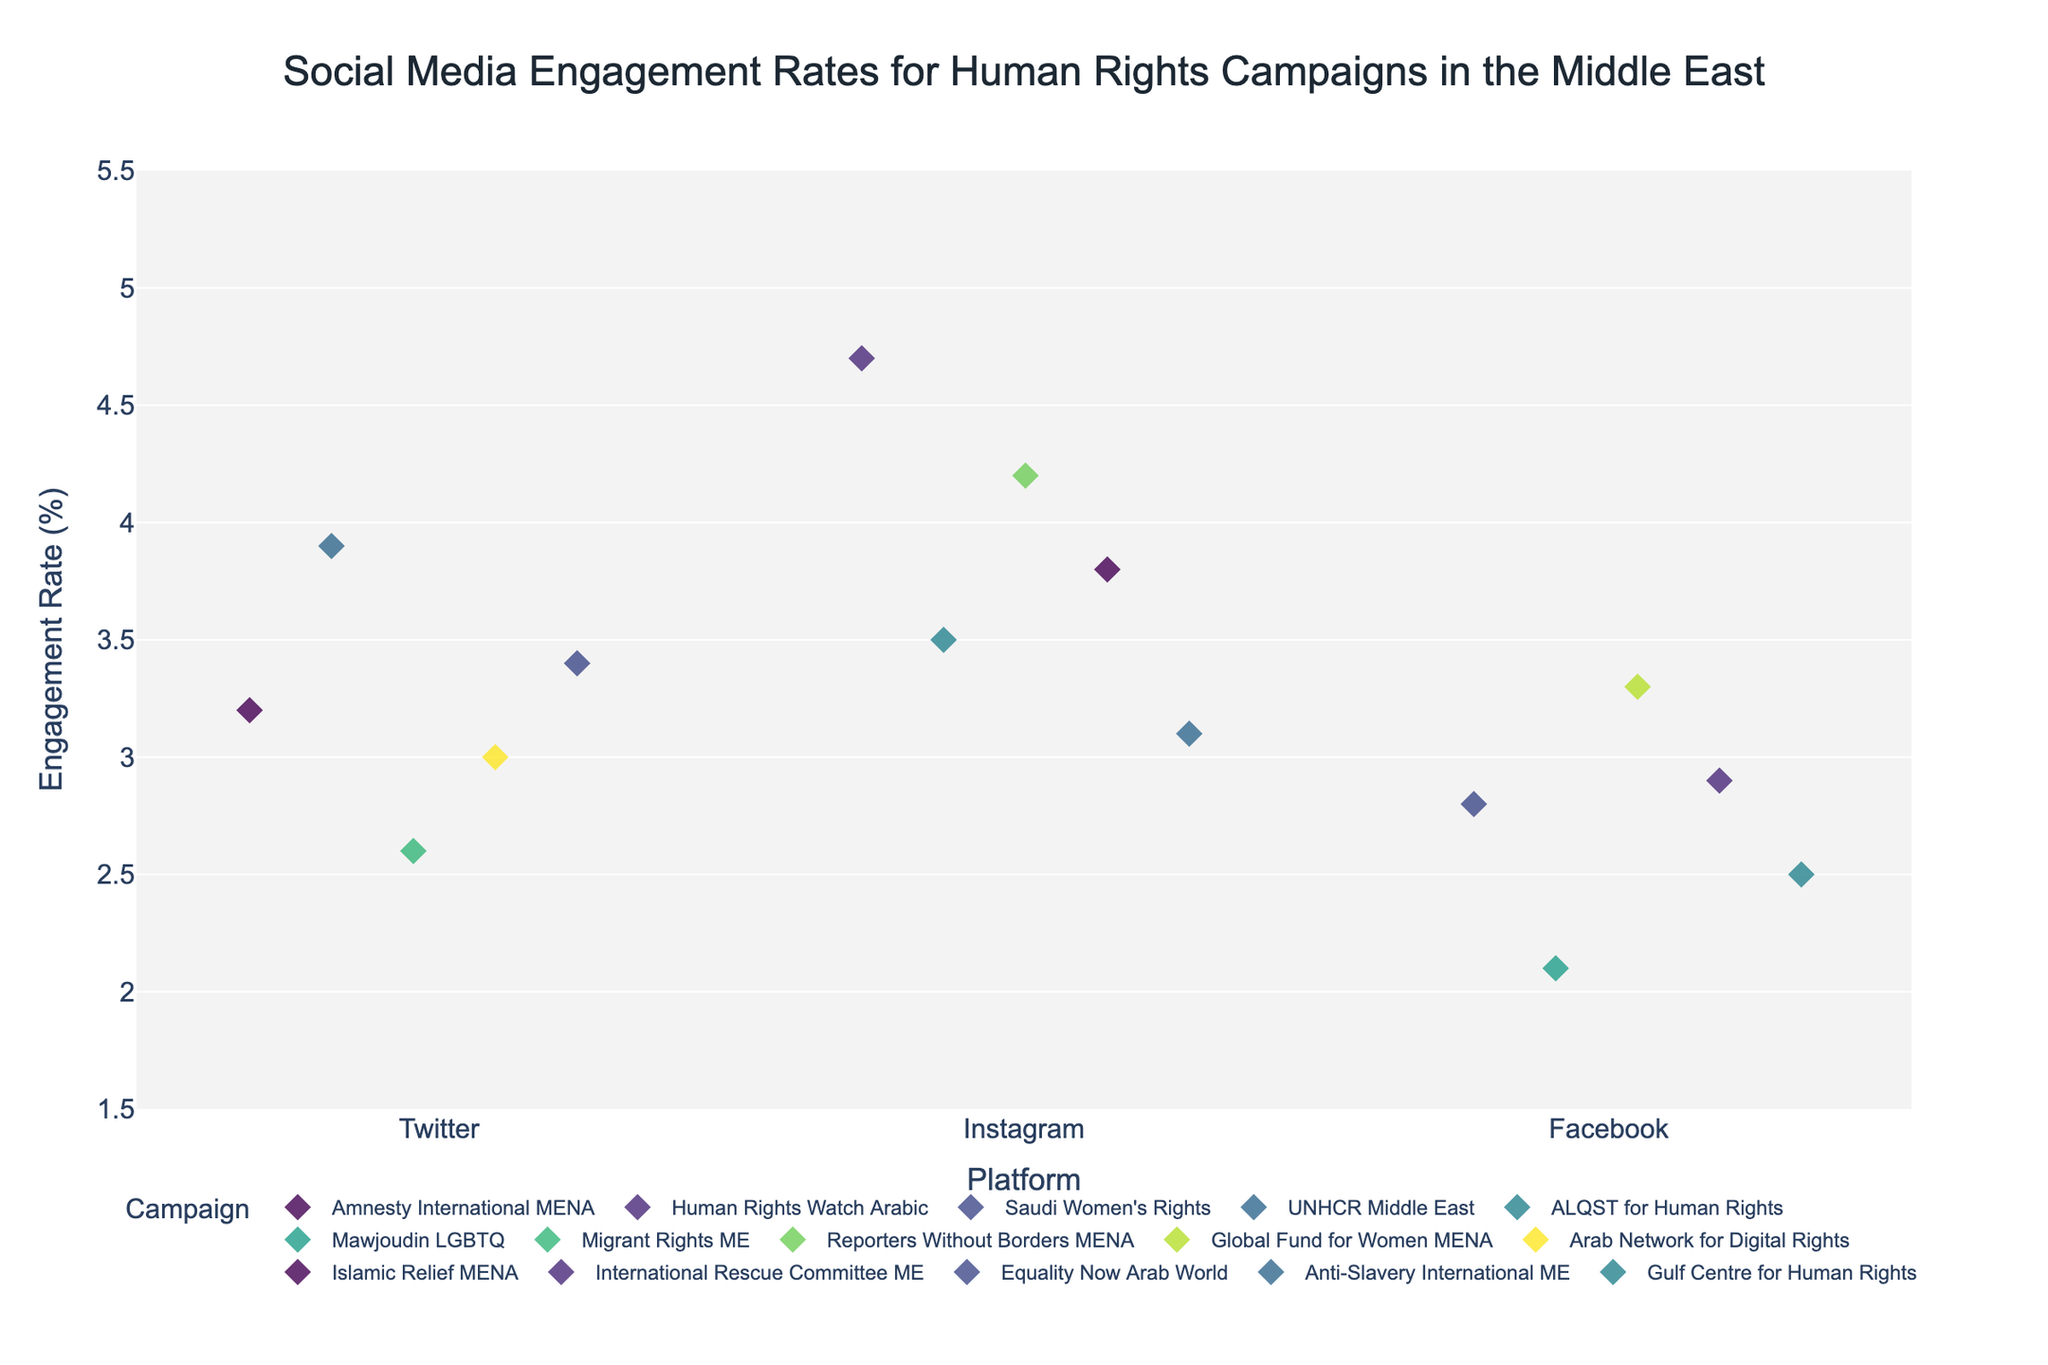Which platform has the highest engagement rate for human rights campaigns? Look at the y-axis values for each platform (Twitter, Instagram, Facebook) and find the highest engagement rate displayed. Instagram has the highest engagement rate with a peak of 4.7%.
Answer: Instagram Which campaign on Facebook has the lowest engagement rate? Identify the data points associated with Facebook and find the one with the lowest value on the y-axis. Mawjoudin LGBTQ has the lowest engagement rate on Facebook at 2.1%.
Answer: Mawjoudin LGBTQ What is the engagement rate range for Twitter? Find the lowest and highest engagement rates associated with Twitter from the y-axis values of the data points. The range is from 2.6% to 3.9%.
Answer: Between 2.6% and 3.9% How many campaigns are shown on Instagram? Count the number of data points aligned with Instagram on the x-axis. There are 5 campaigns shown on Instagram.
Answer: 5 Which platform has the most concentrated engagement rates? Compare the spread of data points on the y-axis for each platform (Twitter, Instagram, Facebook) to see which one has the least spread. Twitter has the most concentrated engagement rates, mostly between 2.6% and 3.9%.
Answer: Twitter What is the average engagement rate for Facebook campaigns? Sum the engagement rates for all Facebook campaigns and divide by the number of Facebook campaigns. The sum of the rates is 2.8 + 2.1 + 3.3 + 2.9 + 2.5 = 13.6, and there are 5 campaigns. So, the average engagement rate is 13.6 / 5 = 2.72%.
Answer: 2.72% Which campaign has the highest engagement rate overall? Identify the data point with the highest value on the y-axis across all platforms. Human Rights Watch Arabic on Instagram has the highest engagement rate at 4.7%.
Answer: Human Rights Watch Arabic Are there any campaigns with the same engagement rate across different platforms? Examine the y-axis values for each data point across all platforms and check if any rates are identical. There are no campaigns with identical engagement rates across different platforms.
Answer: No What is the difference in engagement rate between the highest and lowest campaigns on any platform? Identify the highest and lowest engagement rate values across all platforms, then find their difference. The highest engagement rate is 4.7% (Human Rights Watch Arabic), and the lowest is 2.1% (Mawjoudin LGBTQ), so the difference is 4.7% - 2.1% = 2.6%.
Answer: 2.6% Which campaign on Twitter has a higher engagement rate than Amnesty International MENA? Look at the engagement rate for Amnesty International MENA on Twitter (3.2%) and find campaigns on Twitter with a higher engagement rate. UNHCR Middle East (3.9%), Equality Now Arab World (3.4%) are higher.
Answer: UNHCR Middle East and Equality Now Arab World 